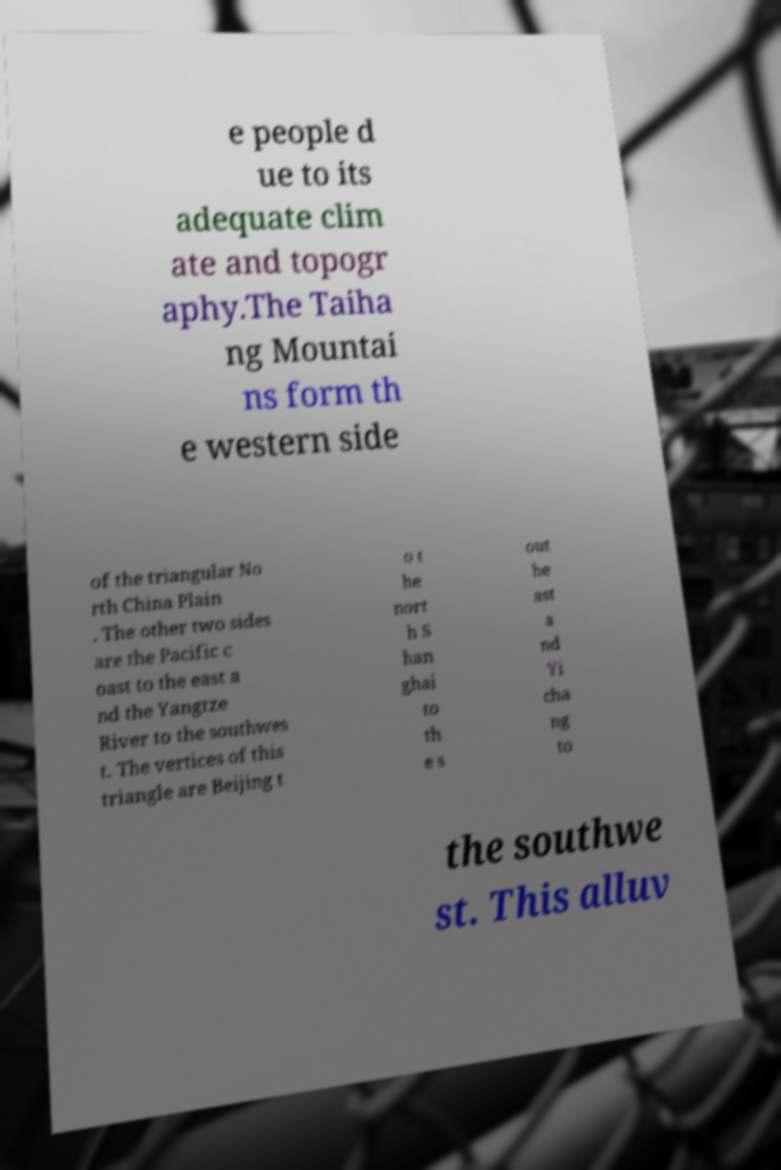Please read and relay the text visible in this image. What does it say? e people d ue to its adequate clim ate and topogr aphy.The Taiha ng Mountai ns form th e western side of the triangular No rth China Plain . The other two sides are the Pacific c oast to the east a nd the Yangtze River to the southwes t. The vertices of this triangle are Beijing t o t he nort h S han ghai to th e s out he ast a nd Yi cha ng to the southwe st. This alluv 